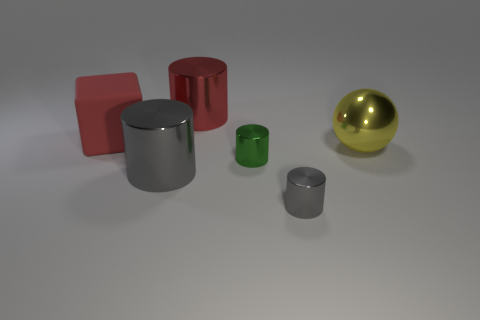How does the light source in the scene affect the appearance of these objects? The light source above the objects creates subtle shadows and highlights, accentuating the differences in material properties. The shiny objects reflect more light, exhibiting clear reflections and specular highlights, whereas the matte objects diffuse the light, exhibiting softer shadows and less pronounced highlights. 